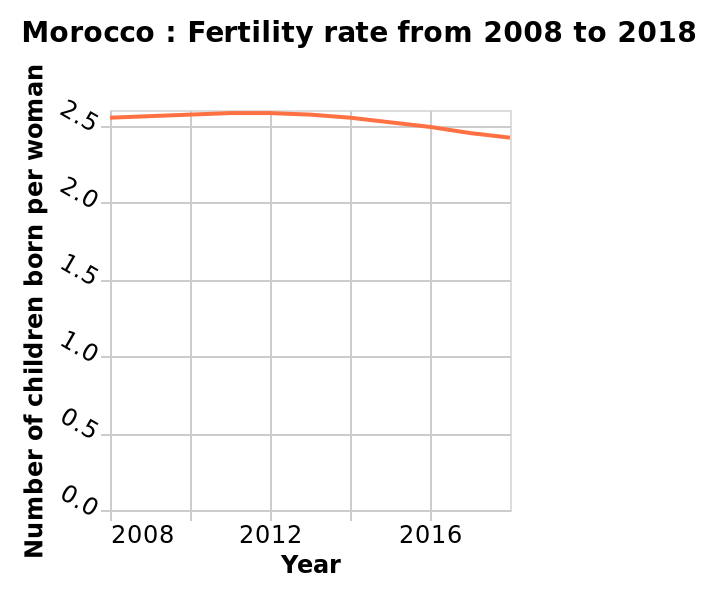<image>
What is the highest value on the y-axis in the graph? The highest value on the y-axis is 2.5, representing the maximum fertility rate of 2.5 children born per woman. What is the average number of children born to Moroccan women?  The average number of children born to Moroccan women is around 2.5. What is the lowest value on the y-axis in the graph? The lowest value on the y-axis is 0.0, representing the minimum fertility rate of 0 children born per woman. 